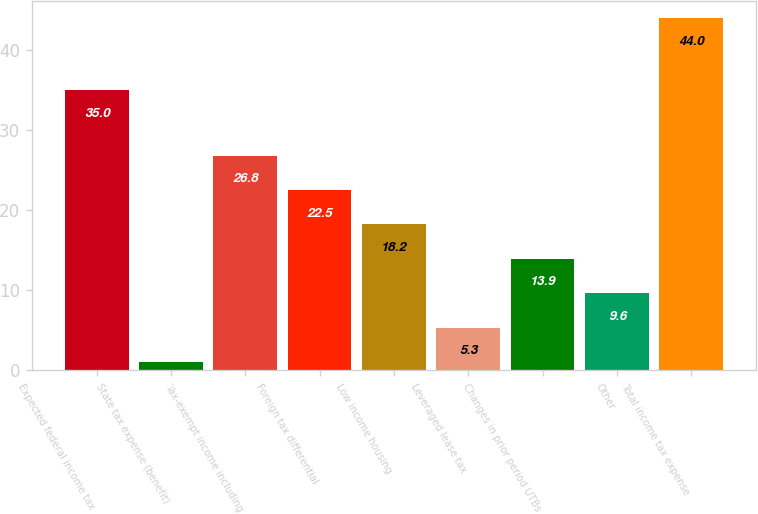<chart> <loc_0><loc_0><loc_500><loc_500><bar_chart><fcel>Expected federal income tax<fcel>State tax expense (benefit)<fcel>Tax-exempt income including<fcel>Foreign tax differential<fcel>Low income housing<fcel>Leveraged lease tax<fcel>Changes in prior period UTBs<fcel>Other<fcel>Total income tax expense<nl><fcel>35<fcel>1<fcel>26.8<fcel>22.5<fcel>18.2<fcel>5.3<fcel>13.9<fcel>9.6<fcel>44<nl></chart> 